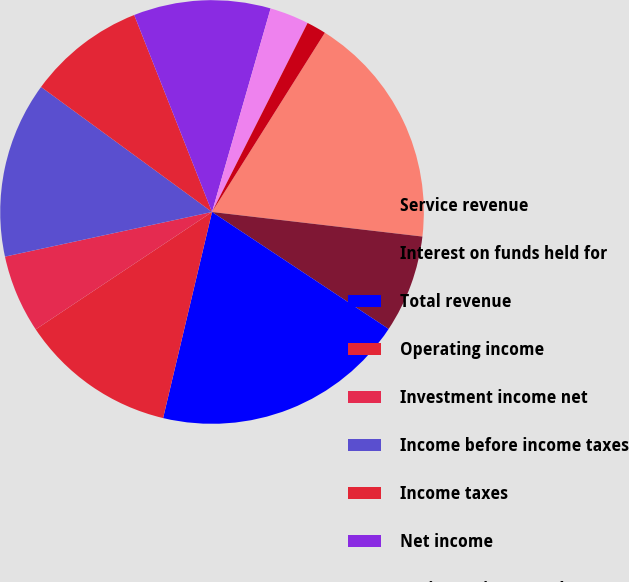<chart> <loc_0><loc_0><loc_500><loc_500><pie_chart><fcel>Service revenue<fcel>Interest on funds held for<fcel>Total revenue<fcel>Operating income<fcel>Investment income net<fcel>Income before income taxes<fcel>Income taxes<fcel>Net income<fcel>Basic earnings per share (1)<fcel>Diluted earnings per share^(1)<nl><fcel>17.91%<fcel>7.46%<fcel>19.4%<fcel>11.94%<fcel>5.97%<fcel>13.43%<fcel>8.96%<fcel>10.45%<fcel>2.99%<fcel>1.49%<nl></chart> 